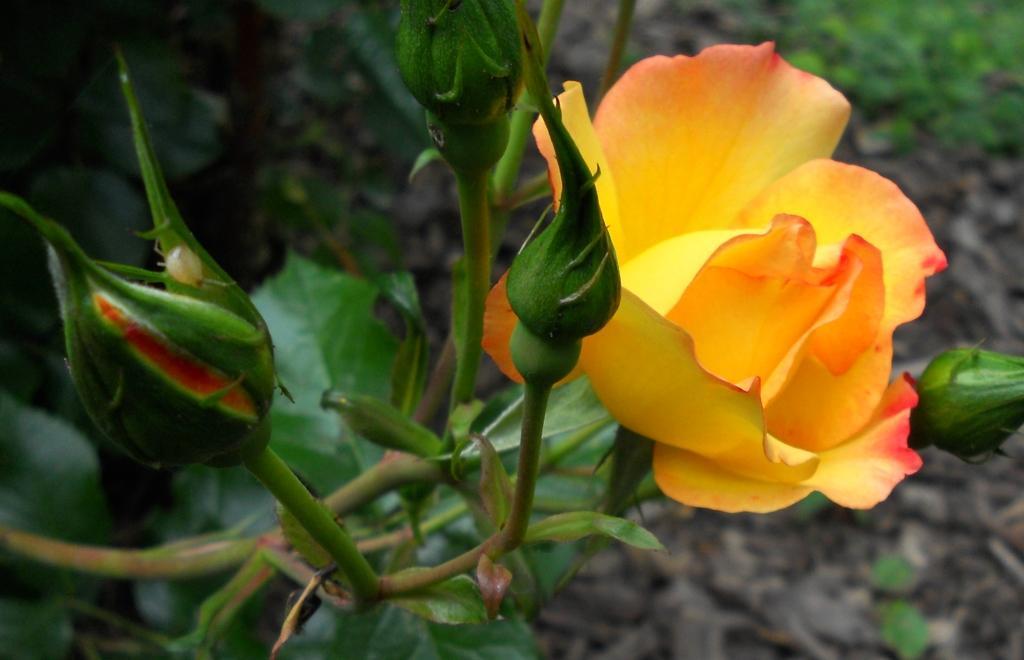Could you give a brief overview of what you see in this image? In this picture there is a rose on the right side of the image and there is a bud on the left side of the image and there is greenery in the background area of the image. 